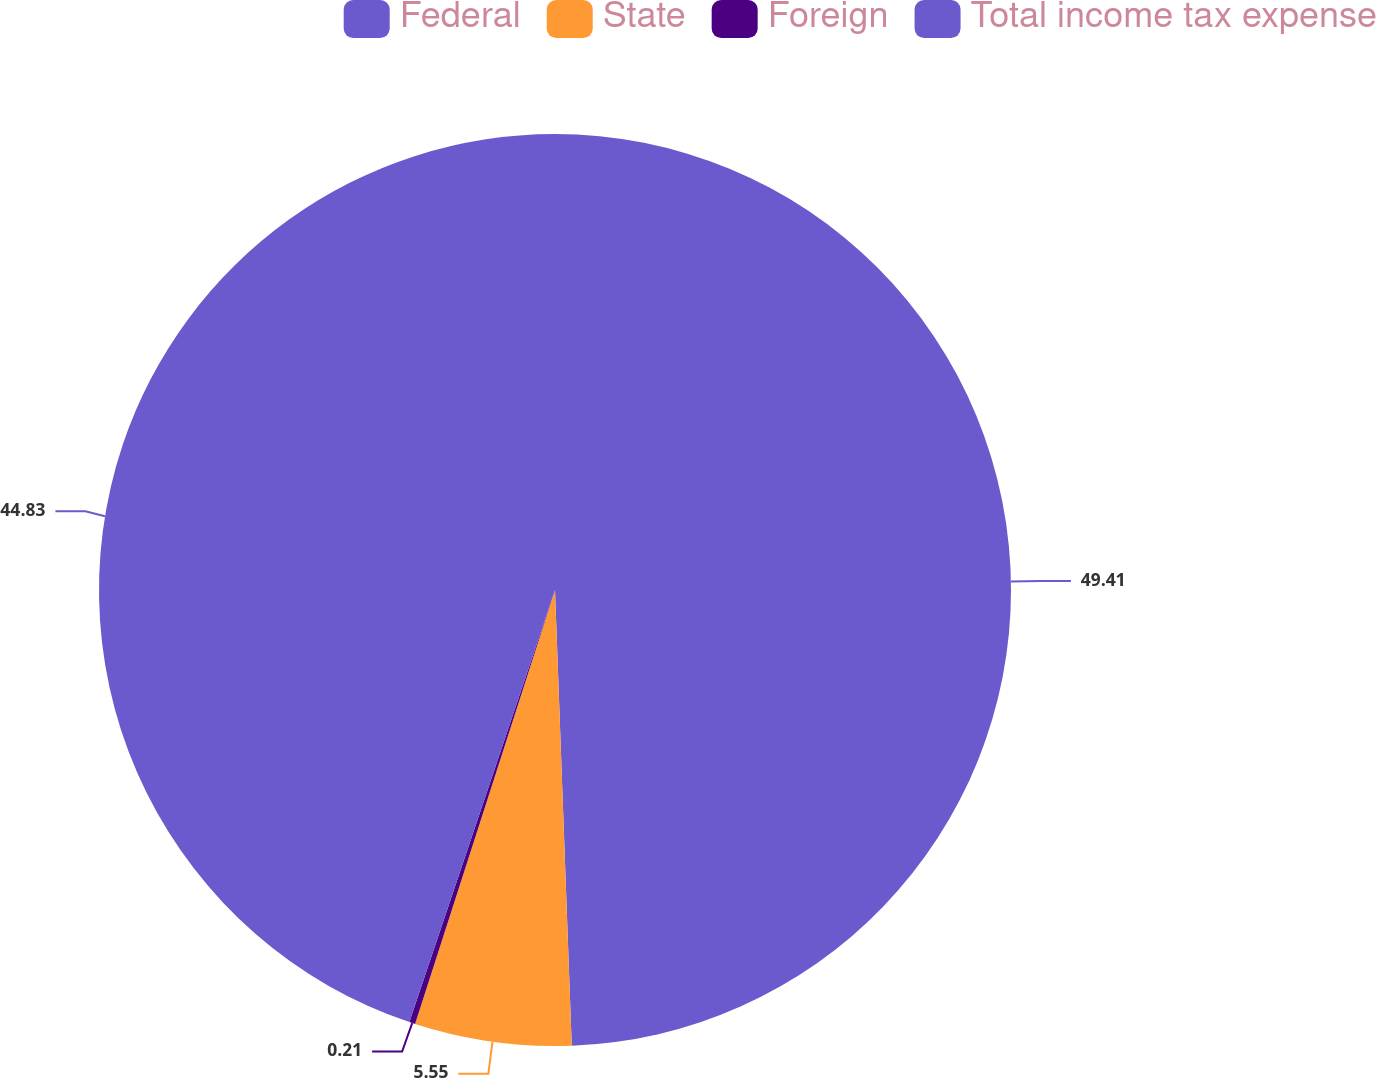<chart> <loc_0><loc_0><loc_500><loc_500><pie_chart><fcel>Federal<fcel>State<fcel>Foreign<fcel>Total income tax expense<nl><fcel>49.42%<fcel>5.55%<fcel>0.21%<fcel>44.83%<nl></chart> 